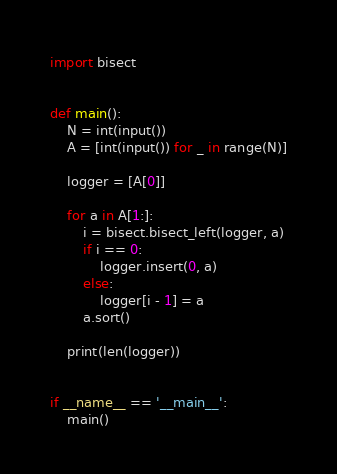Convert code to text. <code><loc_0><loc_0><loc_500><loc_500><_Python_>import bisect


def main():
    N = int(input())
    A = [int(input()) for _ in range(N)]

    logger = [A[0]]

    for a in A[1:]:
        i = bisect.bisect_left(logger, a)
        if i == 0:
            logger.insert(0, a)
        else:
            logger[i - 1] = a
        a.sort()

    print(len(logger))


if __name__ == '__main__':
    main()
</code> 